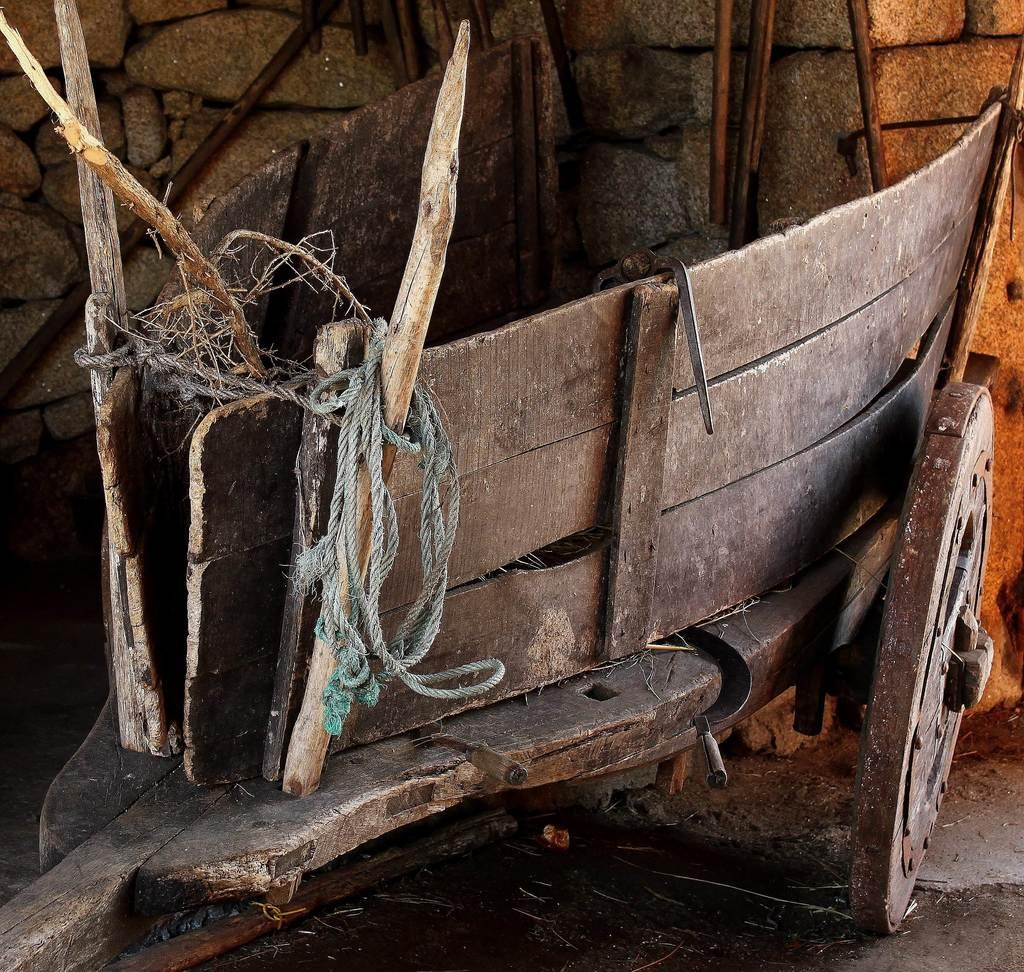What object is located at the front of the image? There is a cart in the front of the image. What is attached to the cart? There is a rope on the cart. What can be seen in the background of the image? There is a wall in the background of the image. How many fingers can be seen touching the wax on the cart in the image? There are no fingers or wax present in the image. 